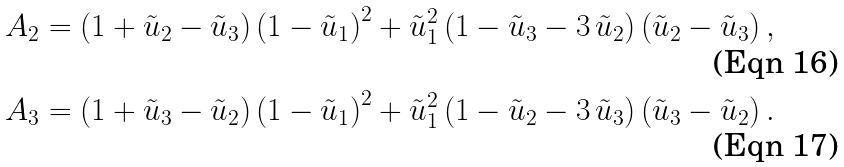Convert formula to latex. <formula><loc_0><loc_0><loc_500><loc_500>A _ { 2 } & = \left ( 1 + \tilde { u } _ { 2 } - \tilde { u } _ { 3 } \right ) \left ( 1 - \tilde { u } _ { 1 } \right ) ^ { 2 } + { \tilde { u } _ { 1 } } ^ { 2 } \left ( 1 - \tilde { u } _ { 3 } - 3 \, \tilde { u } _ { 2 } \right ) \left ( \tilde { u } _ { 2 } - \tilde { u } _ { 3 } \right ) , \\ A _ { 3 } & = \left ( 1 + \tilde { u } _ { 3 } - \tilde { u } _ { 2 } \right ) \left ( 1 - \tilde { u } _ { 1 } \right ) ^ { 2 } + { \tilde { u } _ { 1 } } ^ { 2 } \left ( 1 - \tilde { u } _ { 2 } - 3 \, \tilde { u } _ { 3 } \right ) \left ( \tilde { u } _ { 3 } - \tilde { u } _ { 2 } \right ) .</formula> 